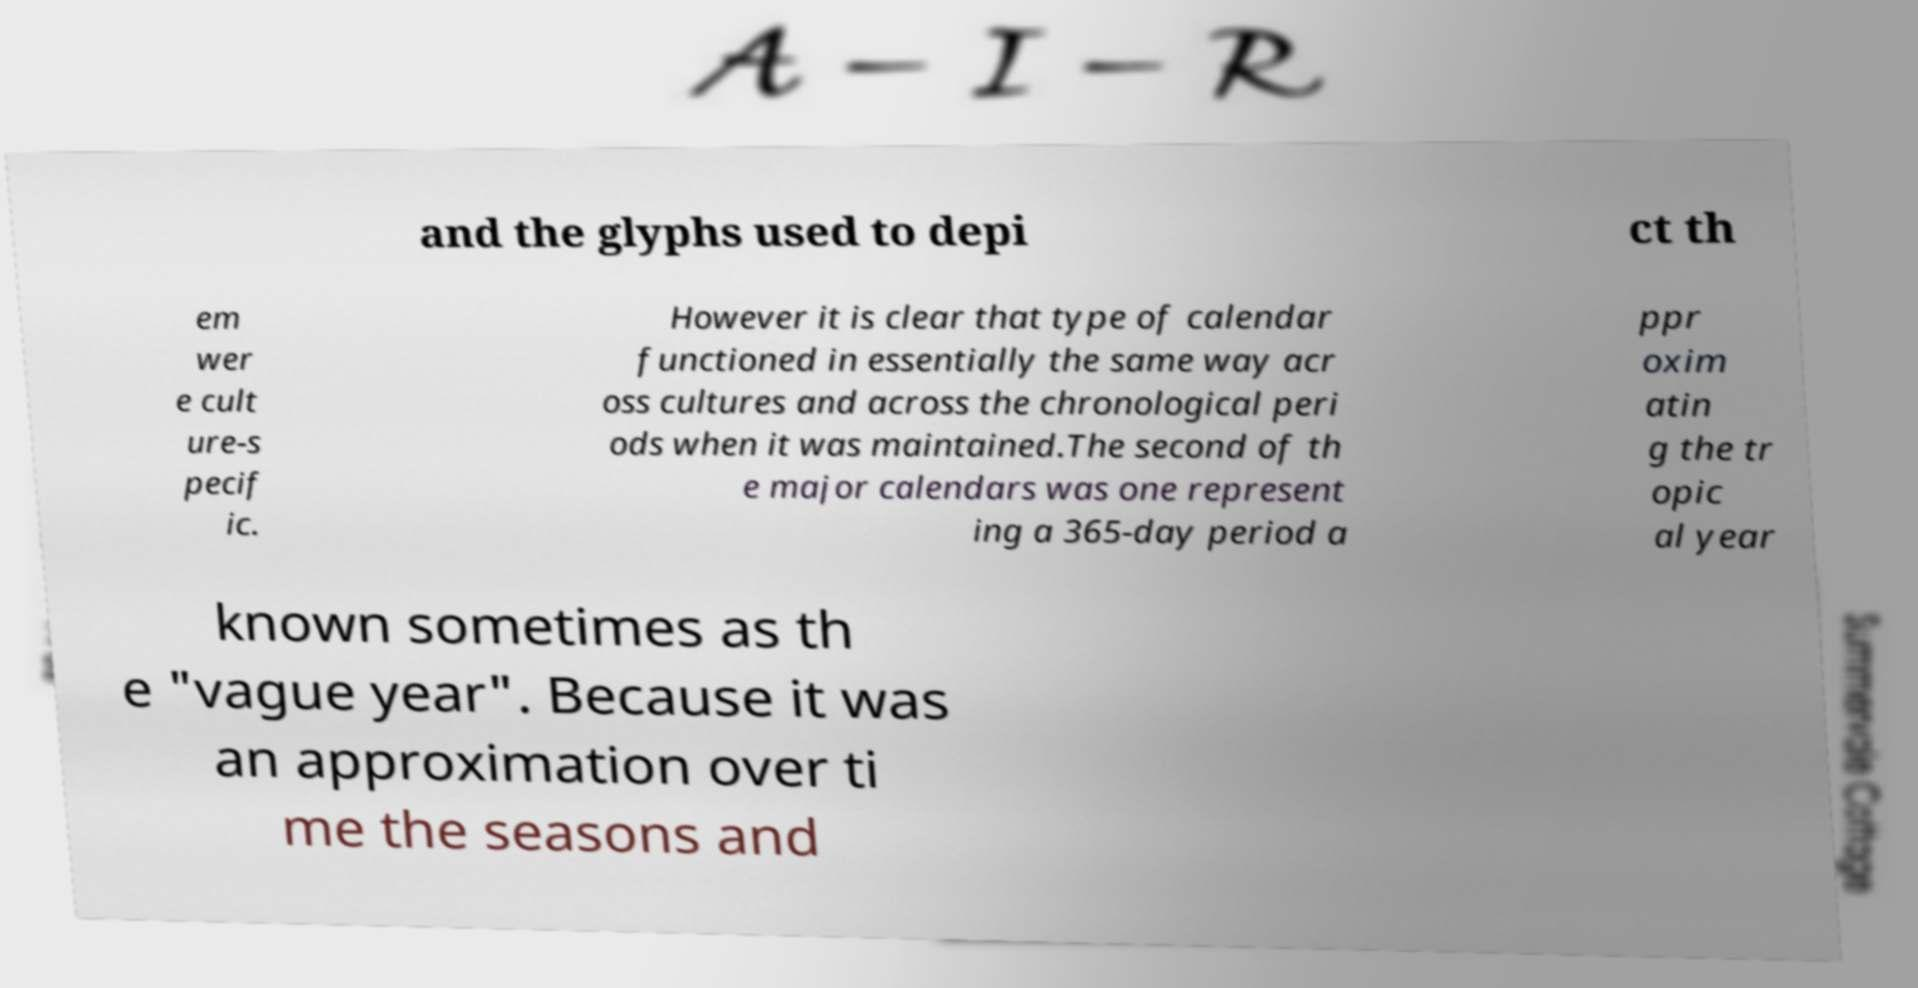Could you extract and type out the text from this image? and the glyphs used to depi ct th em wer e cult ure-s pecif ic. However it is clear that type of calendar functioned in essentially the same way acr oss cultures and across the chronological peri ods when it was maintained.The second of th e major calendars was one represent ing a 365-day period a ppr oxim atin g the tr opic al year known sometimes as th e "vague year". Because it was an approximation over ti me the seasons and 